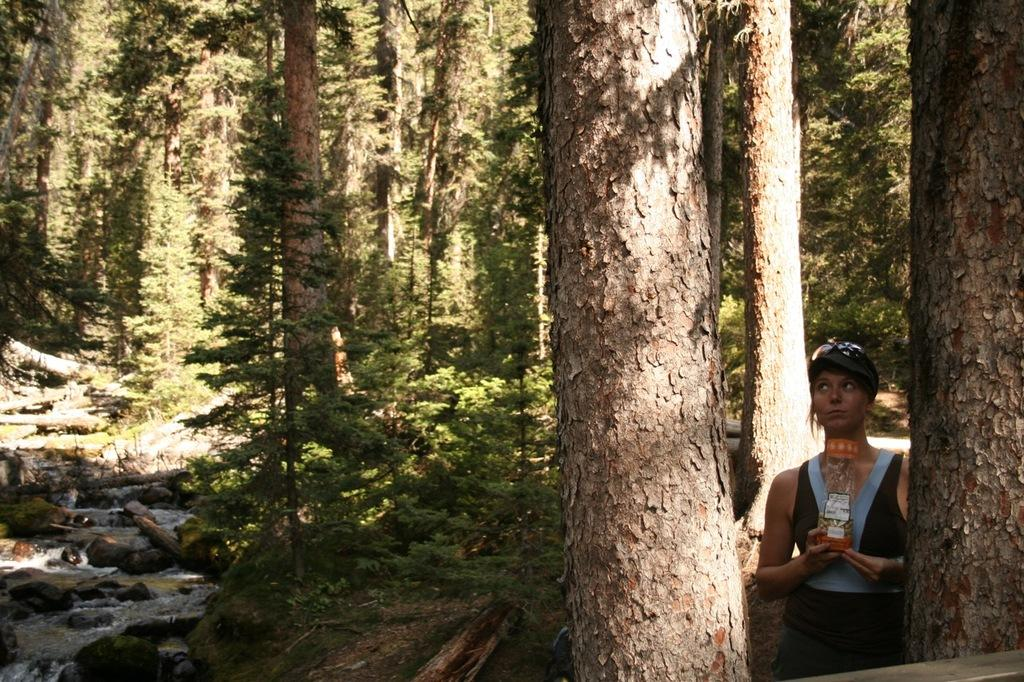Who is the person standing on the right side of the image? There is a woman standing on the right side of the image. What is the woman holding in her hand? The woman is holding a bottle in her hand. What can be seen in the background of the image? There are trees in the background of the image. What type of ground is visible in the image? There is grass on the ground in the image. Can you hear the kettle boiling in the image? There is no kettle present in the image, so it is not possible to hear it boiling. 